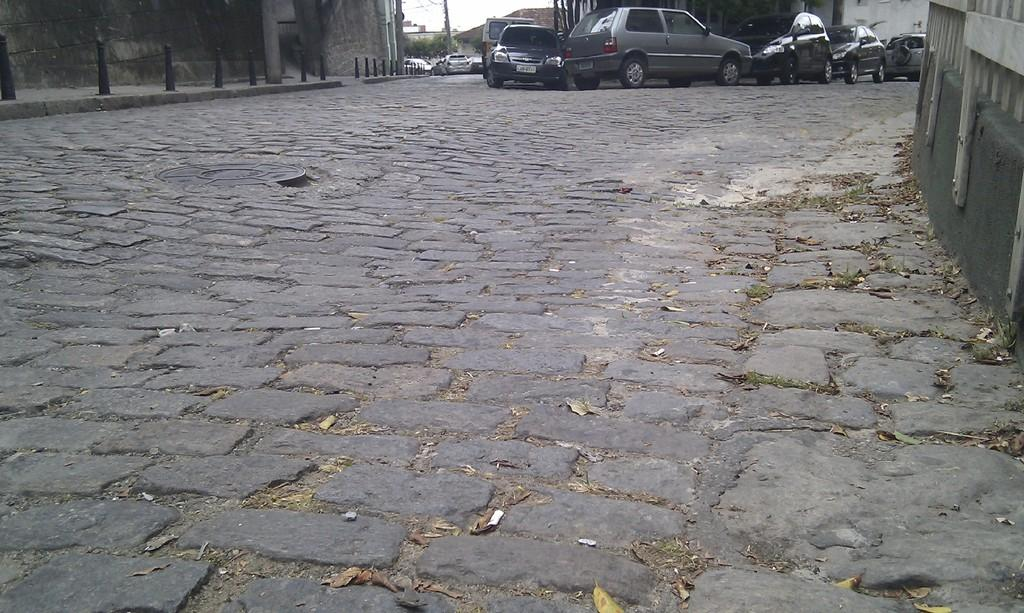What can be seen in the image related to transportation? There is a group of vehicles in the image. What object related to underground infrastructure can be seen on the ground? The lid of a manhole is on the ground. What type of barrier is present in the image? There is a fence in the image. What vertical structures can be seen in the image? There are poles in the image. What type of structure can be seen separating different areas? There is a wall in the image. What type of natural elements are present in the image? Trees are present in the image. What type of human-made structures can be seen in the image? There are buildings in the image. What part of the natural environment is visible in the image? The sky is visible in the image. How many laborers are working on the construction site in the image? There is no construction site or laborers present in the image. What type of sea creature can be seen swimming in the sky in the image? There are no sea creatures, such as jellyfish, present in the image. What type of sewing tool can be seen piercing through the buildings in the image? There are no sewing tools, such as needles, present in the image. 